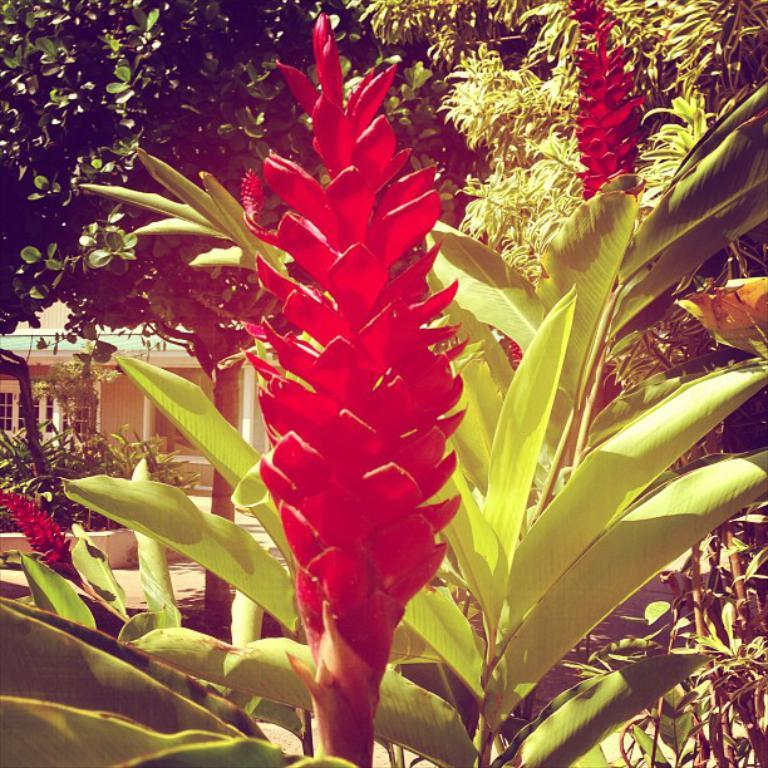What type of vegetation can be seen in the image? There are trees, flowers, and plants in the image. What type of structure is present in the image? There is a building in the image. What type of beetle can be seen crawling on the flowers in the image? There are no beetles present in the image; it only features trees, flowers, plants, and a building. 